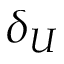Convert formula to latex. <formula><loc_0><loc_0><loc_500><loc_500>\delta _ { U }</formula> 